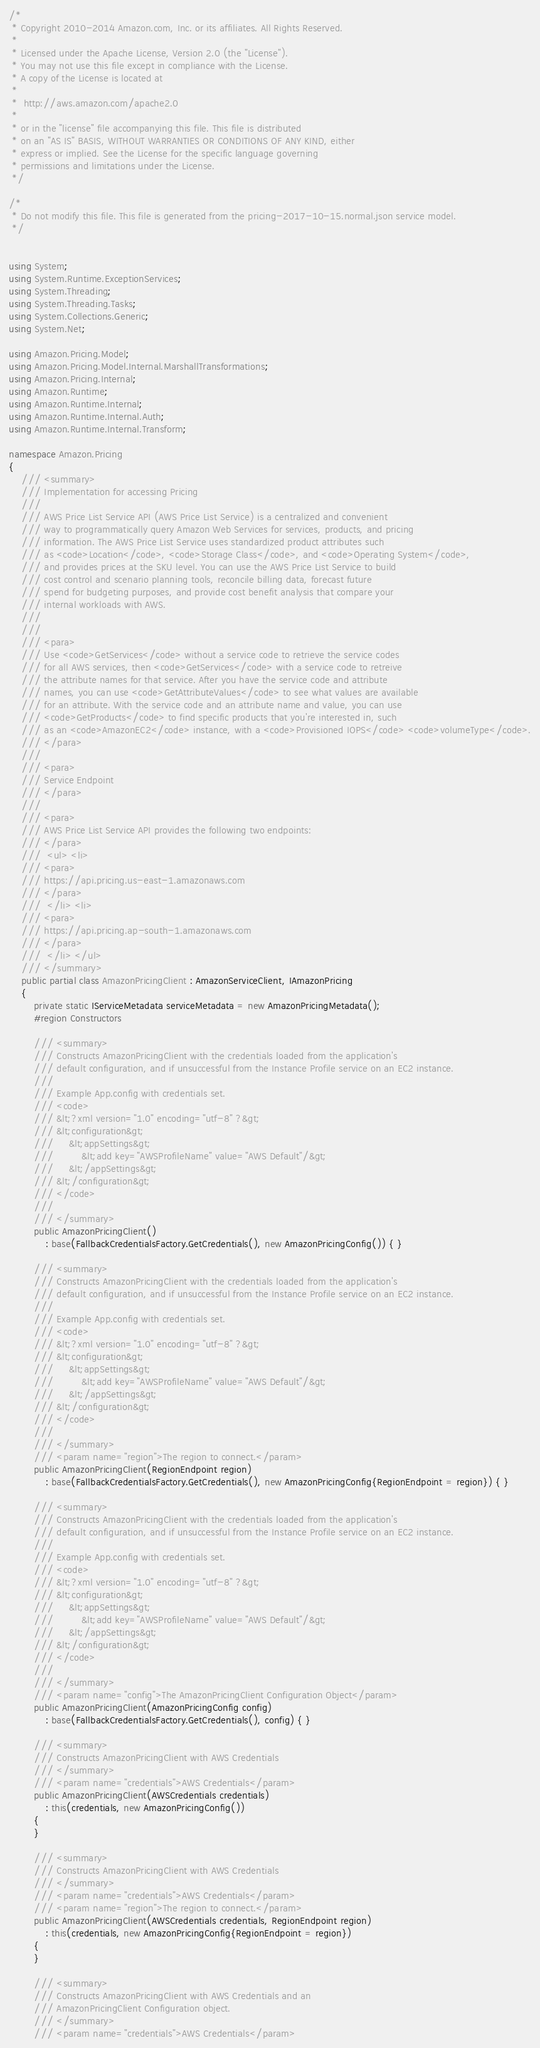<code> <loc_0><loc_0><loc_500><loc_500><_C#_>/*
 * Copyright 2010-2014 Amazon.com, Inc. or its affiliates. All Rights Reserved.
 * 
 * Licensed under the Apache License, Version 2.0 (the "License").
 * You may not use this file except in compliance with the License.
 * A copy of the License is located at
 * 
 *  http://aws.amazon.com/apache2.0
 * 
 * or in the "license" file accompanying this file. This file is distributed
 * on an "AS IS" BASIS, WITHOUT WARRANTIES OR CONDITIONS OF ANY KIND, either
 * express or implied. See the License for the specific language governing
 * permissions and limitations under the License.
 */

/*
 * Do not modify this file. This file is generated from the pricing-2017-10-15.normal.json service model.
 */


using System;
using System.Runtime.ExceptionServices;
using System.Threading;
using System.Threading.Tasks;
using System.Collections.Generic;
using System.Net;

using Amazon.Pricing.Model;
using Amazon.Pricing.Model.Internal.MarshallTransformations;
using Amazon.Pricing.Internal;
using Amazon.Runtime;
using Amazon.Runtime.Internal;
using Amazon.Runtime.Internal.Auth;
using Amazon.Runtime.Internal.Transform;

namespace Amazon.Pricing
{
    /// <summary>
    /// Implementation for accessing Pricing
    ///
    /// AWS Price List Service API (AWS Price List Service) is a centralized and convenient
    /// way to programmatically query Amazon Web Services for services, products, and pricing
    /// information. The AWS Price List Service uses standardized product attributes such
    /// as <code>Location</code>, <code>Storage Class</code>, and <code>Operating System</code>,
    /// and provides prices at the SKU level. You can use the AWS Price List Service to build
    /// cost control and scenario planning tools, reconcile billing data, forecast future
    /// spend for budgeting purposes, and provide cost benefit analysis that compare your
    /// internal workloads with AWS.
    /// 
    ///  
    /// <para>
    /// Use <code>GetServices</code> without a service code to retrieve the service codes
    /// for all AWS services, then <code>GetServices</code> with a service code to retreive
    /// the attribute names for that service. After you have the service code and attribute
    /// names, you can use <code>GetAttributeValues</code> to see what values are available
    /// for an attribute. With the service code and an attribute name and value, you can use
    /// <code>GetProducts</code> to find specific products that you're interested in, such
    /// as an <code>AmazonEC2</code> instance, with a <code>Provisioned IOPS</code> <code>volumeType</code>.
    /// </para>
    ///  
    /// <para>
    /// Service Endpoint
    /// </para>
    ///  
    /// <para>
    /// AWS Price List Service API provides the following two endpoints:
    /// </para>
    ///  <ul> <li> 
    /// <para>
    /// https://api.pricing.us-east-1.amazonaws.com
    /// </para>
    ///  </li> <li> 
    /// <para>
    /// https://api.pricing.ap-south-1.amazonaws.com
    /// </para>
    ///  </li> </ul>
    /// </summary>
    public partial class AmazonPricingClient : AmazonServiceClient, IAmazonPricing
    {
        private static IServiceMetadata serviceMetadata = new AmazonPricingMetadata();
        #region Constructors

        /// <summary>
        /// Constructs AmazonPricingClient with the credentials loaded from the application's
        /// default configuration, and if unsuccessful from the Instance Profile service on an EC2 instance.
        /// 
        /// Example App.config with credentials set. 
        /// <code>
        /// &lt;?xml version="1.0" encoding="utf-8" ?&gt;
        /// &lt;configuration&gt;
        ///     &lt;appSettings&gt;
        ///         &lt;add key="AWSProfileName" value="AWS Default"/&gt;
        ///     &lt;/appSettings&gt;
        /// &lt;/configuration&gt;
        /// </code>
        ///
        /// </summary>
        public AmazonPricingClient()
            : base(FallbackCredentialsFactory.GetCredentials(), new AmazonPricingConfig()) { }

        /// <summary>
        /// Constructs AmazonPricingClient with the credentials loaded from the application's
        /// default configuration, and if unsuccessful from the Instance Profile service on an EC2 instance.
        /// 
        /// Example App.config with credentials set. 
        /// <code>
        /// &lt;?xml version="1.0" encoding="utf-8" ?&gt;
        /// &lt;configuration&gt;
        ///     &lt;appSettings&gt;
        ///         &lt;add key="AWSProfileName" value="AWS Default"/&gt;
        ///     &lt;/appSettings&gt;
        /// &lt;/configuration&gt;
        /// </code>
        ///
        /// </summary>
        /// <param name="region">The region to connect.</param>
        public AmazonPricingClient(RegionEndpoint region)
            : base(FallbackCredentialsFactory.GetCredentials(), new AmazonPricingConfig{RegionEndpoint = region}) { }

        /// <summary>
        /// Constructs AmazonPricingClient with the credentials loaded from the application's
        /// default configuration, and if unsuccessful from the Instance Profile service on an EC2 instance.
        /// 
        /// Example App.config with credentials set. 
        /// <code>
        /// &lt;?xml version="1.0" encoding="utf-8" ?&gt;
        /// &lt;configuration&gt;
        ///     &lt;appSettings&gt;
        ///         &lt;add key="AWSProfileName" value="AWS Default"/&gt;
        ///     &lt;/appSettings&gt;
        /// &lt;/configuration&gt;
        /// </code>
        ///
        /// </summary>
        /// <param name="config">The AmazonPricingClient Configuration Object</param>
        public AmazonPricingClient(AmazonPricingConfig config)
            : base(FallbackCredentialsFactory.GetCredentials(), config) { }

        /// <summary>
        /// Constructs AmazonPricingClient with AWS Credentials
        /// </summary>
        /// <param name="credentials">AWS Credentials</param>
        public AmazonPricingClient(AWSCredentials credentials)
            : this(credentials, new AmazonPricingConfig())
        {
        }

        /// <summary>
        /// Constructs AmazonPricingClient with AWS Credentials
        /// </summary>
        /// <param name="credentials">AWS Credentials</param>
        /// <param name="region">The region to connect.</param>
        public AmazonPricingClient(AWSCredentials credentials, RegionEndpoint region)
            : this(credentials, new AmazonPricingConfig{RegionEndpoint = region})
        {
        }

        /// <summary>
        /// Constructs AmazonPricingClient with AWS Credentials and an
        /// AmazonPricingClient Configuration object.
        /// </summary>
        /// <param name="credentials">AWS Credentials</param></code> 